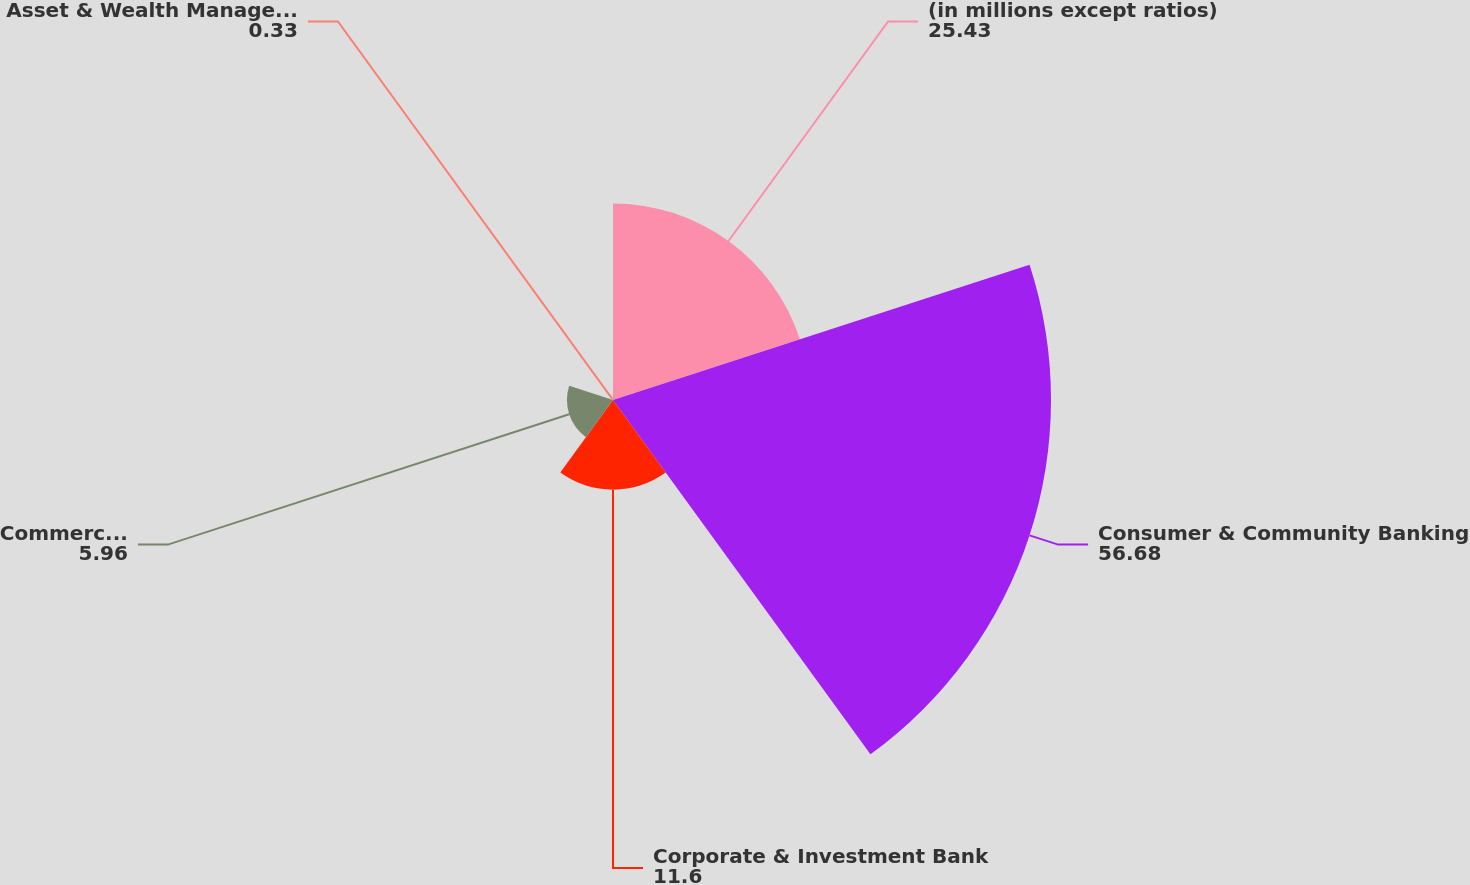Convert chart. <chart><loc_0><loc_0><loc_500><loc_500><pie_chart><fcel>(in millions except ratios)<fcel>Consumer & Community Banking<fcel>Corporate & Investment Bank<fcel>Commercial Banking<fcel>Asset & Wealth Management<nl><fcel>25.43%<fcel>56.68%<fcel>11.6%<fcel>5.96%<fcel>0.33%<nl></chart> 